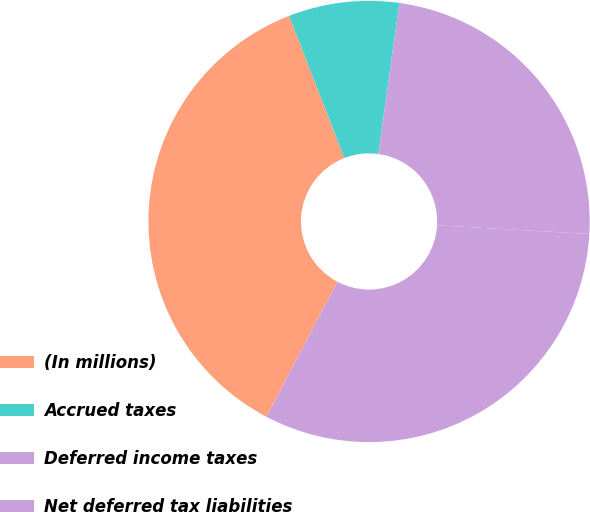Convert chart to OTSL. <chart><loc_0><loc_0><loc_500><loc_500><pie_chart><fcel>(In millions)<fcel>Accrued taxes<fcel>Deferred income taxes<fcel>Net deferred tax liabilities<nl><fcel>36.4%<fcel>8.09%<fcel>23.71%<fcel>31.8%<nl></chart> 